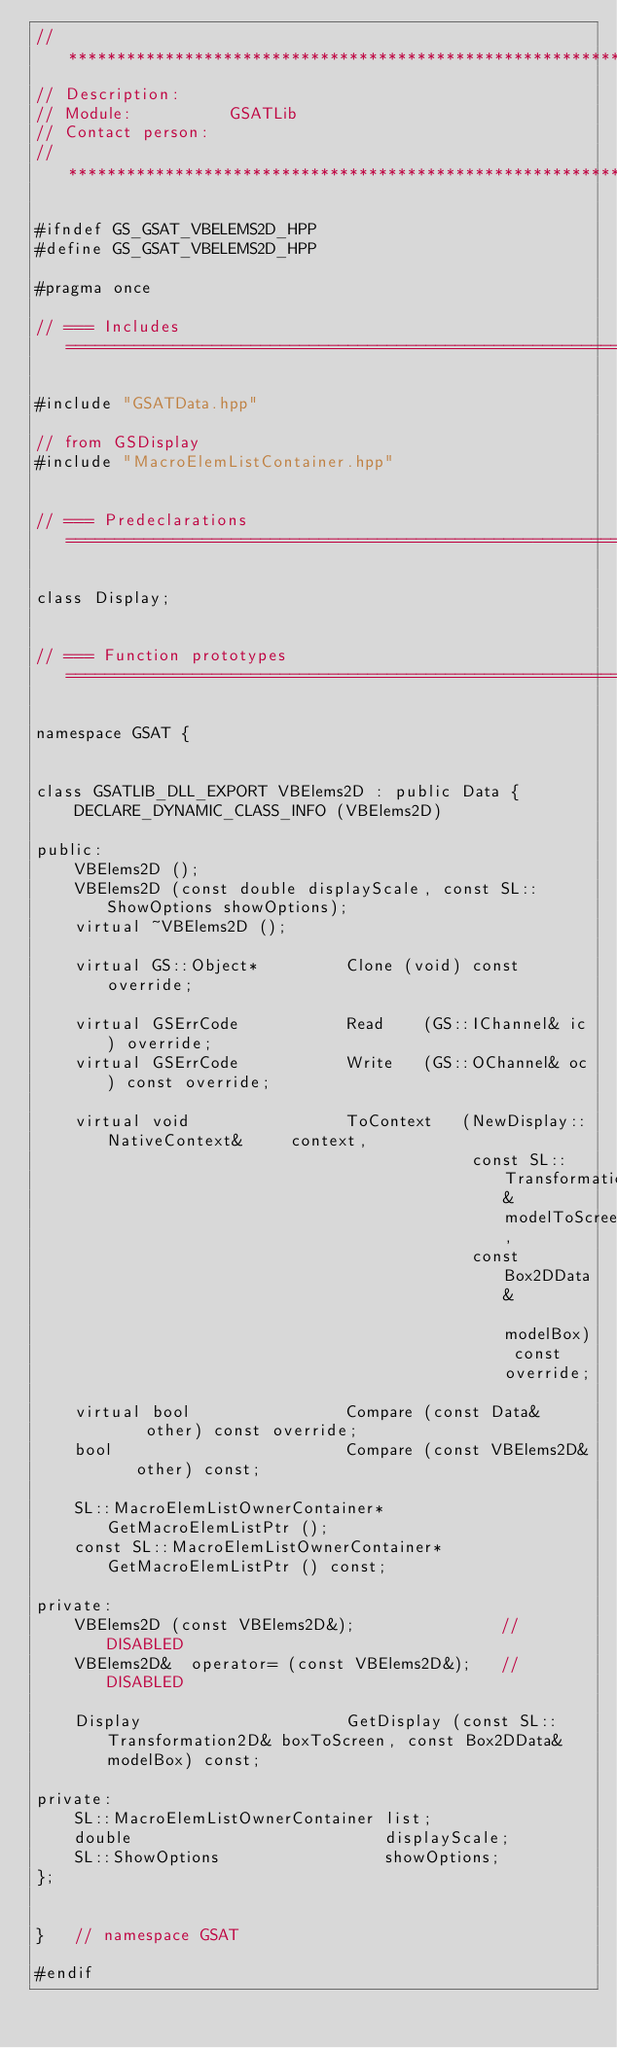Convert code to text. <code><loc_0><loc_0><loc_500><loc_500><_C++_>// *********************************************************************************************************************
// Description:		
// Module:			GSATLib
// Contact person:	
// *********************************************************************************************************************

#ifndef GS_GSAT_VBELEMS2D_HPP
#define GS_GSAT_VBELEMS2D_HPP

#pragma once

// === Includes ========================================================================================================

#include "GSATData.hpp"

// from GSDisplay
#include "MacroElemListContainer.hpp"


// === Predeclarations =================================================================================================

class Display;


// === Function prototypes  ============================================================================================

namespace GSAT {


class GSATLIB_DLL_EXPORT VBElems2D : public Data {
	DECLARE_DYNAMIC_CLASS_INFO (VBElems2D)

public:
	VBElems2D ();
	VBElems2D (const double displayScale, const SL::ShowOptions showOptions);
	virtual ~VBElems2D ();

	virtual GS::Object*			Clone (void) const override;

	virtual GSErrCode			Read	(GS::IChannel& ic) override;
	virtual GSErrCode			Write	(GS::OChannel& oc) const override;
	
	virtual void				ToContext	(NewDisplay::NativeContext&		context,
											 const SL::Transformation2D&	modelToScreen,
											 const Box2DData&				modelBox) const override;
	
	virtual bool				Compare (const Data&		other) const override;
	bool 						Compare (const VBElems2D&	other) const;

	SL::MacroElemListOwnerContainer*			GetMacroElemListPtr ();
	const SL::MacroElemListOwnerContainer*		GetMacroElemListPtr () const;

private:
	VBElems2D (const VBElems2D&);				// DISABLED
	VBElems2D&	operator= (const VBElems2D&);	// DISABLED

	Display						GetDisplay (const SL::Transformation2D& boxToScreen, const Box2DData& modelBox) const;

private:
	SL::MacroElemListOwnerContainer	list;
	double							displayScale;
	SL::ShowOptions					showOptions;
};


}	// namespace GSAT

#endif
</code> 